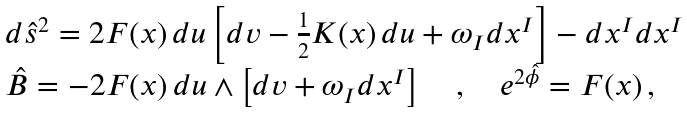<formula> <loc_0><loc_0><loc_500><loc_500>\begin{array} { l } d { \hat { s } } ^ { 2 } = 2 F ( x ) \, d u \left [ d v - \frac { 1 } { 2 } K ( x ) \, d u + \omega _ { I } d x ^ { I } \right ] - d x ^ { I } d x ^ { I } \\ \hat { B } = - 2 F ( x ) \, d u \wedge \left [ d v + \omega _ { I } d x ^ { I } \right ] \quad , \quad e ^ { 2 \hat { \phi } } = F ( x ) \, , \end{array}</formula> 